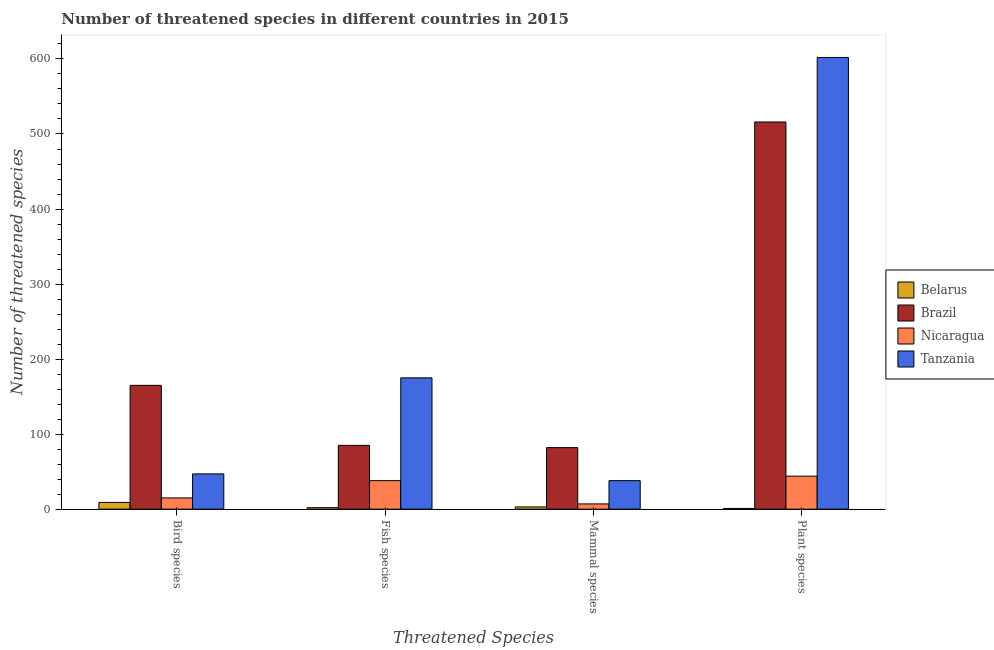How many groups of bars are there?
Make the answer very short. 4. Are the number of bars per tick equal to the number of legend labels?
Your answer should be very brief. Yes. Are the number of bars on each tick of the X-axis equal?
Provide a succinct answer. Yes. How many bars are there on the 1st tick from the left?
Your response must be concise. 4. How many bars are there on the 4th tick from the right?
Your answer should be very brief. 4. What is the label of the 1st group of bars from the left?
Make the answer very short. Bird species. What is the number of threatened bird species in Brazil?
Provide a succinct answer. 165. Across all countries, what is the maximum number of threatened mammal species?
Offer a terse response. 82. Across all countries, what is the minimum number of threatened fish species?
Give a very brief answer. 2. In which country was the number of threatened bird species maximum?
Offer a very short reply. Brazil. In which country was the number of threatened mammal species minimum?
Make the answer very short. Belarus. What is the total number of threatened fish species in the graph?
Provide a succinct answer. 300. What is the difference between the number of threatened plant species in Belarus and that in Tanzania?
Ensure brevity in your answer.  -601. What is the difference between the number of threatened bird species in Tanzania and the number of threatened plant species in Belarus?
Offer a terse response. 46. What is the average number of threatened fish species per country?
Make the answer very short. 75. What is the difference between the number of threatened plant species and number of threatened mammal species in Nicaragua?
Offer a terse response. 37. What is the ratio of the number of threatened bird species in Tanzania to that in Brazil?
Provide a short and direct response. 0.28. Is the number of threatened bird species in Brazil less than that in Belarus?
Give a very brief answer. No. What is the difference between the highest and the second highest number of threatened bird species?
Your answer should be compact. 118. What is the difference between the highest and the lowest number of threatened fish species?
Your answer should be very brief. 173. In how many countries, is the number of threatened mammal species greater than the average number of threatened mammal species taken over all countries?
Provide a succinct answer. 2. Is the sum of the number of threatened bird species in Nicaragua and Belarus greater than the maximum number of threatened mammal species across all countries?
Your response must be concise. No. Is it the case that in every country, the sum of the number of threatened plant species and number of threatened mammal species is greater than the sum of number of threatened bird species and number of threatened fish species?
Your response must be concise. No. What does the 3rd bar from the left in Plant species represents?
Offer a terse response. Nicaragua. What does the 2nd bar from the right in Plant species represents?
Keep it short and to the point. Nicaragua. Is it the case that in every country, the sum of the number of threatened bird species and number of threatened fish species is greater than the number of threatened mammal species?
Your answer should be compact. Yes. Are all the bars in the graph horizontal?
Your answer should be very brief. No. How many countries are there in the graph?
Provide a succinct answer. 4. What is the title of the graph?
Offer a terse response. Number of threatened species in different countries in 2015. What is the label or title of the X-axis?
Your answer should be compact. Threatened Species. What is the label or title of the Y-axis?
Offer a very short reply. Number of threatened species. What is the Number of threatened species of Brazil in Bird species?
Your answer should be very brief. 165. What is the Number of threatened species of Belarus in Fish species?
Ensure brevity in your answer.  2. What is the Number of threatened species in Brazil in Fish species?
Your answer should be very brief. 85. What is the Number of threatened species of Tanzania in Fish species?
Keep it short and to the point. 175. What is the Number of threatened species of Nicaragua in Mammal species?
Your answer should be compact. 7. What is the Number of threatened species in Tanzania in Mammal species?
Offer a very short reply. 38. What is the Number of threatened species of Belarus in Plant species?
Keep it short and to the point. 1. What is the Number of threatened species of Brazil in Plant species?
Provide a short and direct response. 516. What is the Number of threatened species of Tanzania in Plant species?
Make the answer very short. 602. Across all Threatened Species, what is the maximum Number of threatened species of Brazil?
Give a very brief answer. 516. Across all Threatened Species, what is the maximum Number of threatened species in Tanzania?
Provide a succinct answer. 602. Across all Threatened Species, what is the minimum Number of threatened species in Brazil?
Provide a short and direct response. 82. Across all Threatened Species, what is the minimum Number of threatened species in Nicaragua?
Offer a terse response. 7. What is the total Number of threatened species in Brazil in the graph?
Your answer should be very brief. 848. What is the total Number of threatened species of Nicaragua in the graph?
Your answer should be compact. 104. What is the total Number of threatened species of Tanzania in the graph?
Make the answer very short. 862. What is the difference between the Number of threatened species in Brazil in Bird species and that in Fish species?
Provide a short and direct response. 80. What is the difference between the Number of threatened species in Tanzania in Bird species and that in Fish species?
Provide a short and direct response. -128. What is the difference between the Number of threatened species of Tanzania in Bird species and that in Mammal species?
Provide a succinct answer. 9. What is the difference between the Number of threatened species of Belarus in Bird species and that in Plant species?
Provide a succinct answer. 8. What is the difference between the Number of threatened species in Brazil in Bird species and that in Plant species?
Keep it short and to the point. -351. What is the difference between the Number of threatened species in Tanzania in Bird species and that in Plant species?
Give a very brief answer. -555. What is the difference between the Number of threatened species of Brazil in Fish species and that in Mammal species?
Offer a terse response. 3. What is the difference between the Number of threatened species of Tanzania in Fish species and that in Mammal species?
Your answer should be compact. 137. What is the difference between the Number of threatened species in Brazil in Fish species and that in Plant species?
Your response must be concise. -431. What is the difference between the Number of threatened species of Nicaragua in Fish species and that in Plant species?
Ensure brevity in your answer.  -6. What is the difference between the Number of threatened species of Tanzania in Fish species and that in Plant species?
Keep it short and to the point. -427. What is the difference between the Number of threatened species of Belarus in Mammal species and that in Plant species?
Make the answer very short. 2. What is the difference between the Number of threatened species in Brazil in Mammal species and that in Plant species?
Give a very brief answer. -434. What is the difference between the Number of threatened species in Nicaragua in Mammal species and that in Plant species?
Ensure brevity in your answer.  -37. What is the difference between the Number of threatened species in Tanzania in Mammal species and that in Plant species?
Your answer should be compact. -564. What is the difference between the Number of threatened species of Belarus in Bird species and the Number of threatened species of Brazil in Fish species?
Ensure brevity in your answer.  -76. What is the difference between the Number of threatened species of Belarus in Bird species and the Number of threatened species of Nicaragua in Fish species?
Give a very brief answer. -29. What is the difference between the Number of threatened species of Belarus in Bird species and the Number of threatened species of Tanzania in Fish species?
Your answer should be very brief. -166. What is the difference between the Number of threatened species in Brazil in Bird species and the Number of threatened species in Nicaragua in Fish species?
Provide a succinct answer. 127. What is the difference between the Number of threatened species in Nicaragua in Bird species and the Number of threatened species in Tanzania in Fish species?
Your response must be concise. -160. What is the difference between the Number of threatened species in Belarus in Bird species and the Number of threatened species in Brazil in Mammal species?
Provide a short and direct response. -73. What is the difference between the Number of threatened species of Belarus in Bird species and the Number of threatened species of Tanzania in Mammal species?
Give a very brief answer. -29. What is the difference between the Number of threatened species of Brazil in Bird species and the Number of threatened species of Nicaragua in Mammal species?
Make the answer very short. 158. What is the difference between the Number of threatened species of Brazil in Bird species and the Number of threatened species of Tanzania in Mammal species?
Offer a terse response. 127. What is the difference between the Number of threatened species of Belarus in Bird species and the Number of threatened species of Brazil in Plant species?
Keep it short and to the point. -507. What is the difference between the Number of threatened species of Belarus in Bird species and the Number of threatened species of Nicaragua in Plant species?
Keep it short and to the point. -35. What is the difference between the Number of threatened species of Belarus in Bird species and the Number of threatened species of Tanzania in Plant species?
Your answer should be compact. -593. What is the difference between the Number of threatened species in Brazil in Bird species and the Number of threatened species in Nicaragua in Plant species?
Your response must be concise. 121. What is the difference between the Number of threatened species of Brazil in Bird species and the Number of threatened species of Tanzania in Plant species?
Your answer should be compact. -437. What is the difference between the Number of threatened species in Nicaragua in Bird species and the Number of threatened species in Tanzania in Plant species?
Offer a terse response. -587. What is the difference between the Number of threatened species in Belarus in Fish species and the Number of threatened species in Brazil in Mammal species?
Provide a succinct answer. -80. What is the difference between the Number of threatened species in Belarus in Fish species and the Number of threatened species in Tanzania in Mammal species?
Your response must be concise. -36. What is the difference between the Number of threatened species of Brazil in Fish species and the Number of threatened species of Tanzania in Mammal species?
Your answer should be very brief. 47. What is the difference between the Number of threatened species in Nicaragua in Fish species and the Number of threatened species in Tanzania in Mammal species?
Ensure brevity in your answer.  0. What is the difference between the Number of threatened species of Belarus in Fish species and the Number of threatened species of Brazil in Plant species?
Your answer should be very brief. -514. What is the difference between the Number of threatened species in Belarus in Fish species and the Number of threatened species in Nicaragua in Plant species?
Provide a short and direct response. -42. What is the difference between the Number of threatened species of Belarus in Fish species and the Number of threatened species of Tanzania in Plant species?
Make the answer very short. -600. What is the difference between the Number of threatened species in Brazil in Fish species and the Number of threatened species in Tanzania in Plant species?
Provide a short and direct response. -517. What is the difference between the Number of threatened species in Nicaragua in Fish species and the Number of threatened species in Tanzania in Plant species?
Your answer should be compact. -564. What is the difference between the Number of threatened species in Belarus in Mammal species and the Number of threatened species in Brazil in Plant species?
Keep it short and to the point. -513. What is the difference between the Number of threatened species of Belarus in Mammal species and the Number of threatened species of Nicaragua in Plant species?
Your response must be concise. -41. What is the difference between the Number of threatened species in Belarus in Mammal species and the Number of threatened species in Tanzania in Plant species?
Offer a terse response. -599. What is the difference between the Number of threatened species in Brazil in Mammal species and the Number of threatened species in Tanzania in Plant species?
Offer a terse response. -520. What is the difference between the Number of threatened species of Nicaragua in Mammal species and the Number of threatened species of Tanzania in Plant species?
Offer a terse response. -595. What is the average Number of threatened species of Belarus per Threatened Species?
Provide a succinct answer. 3.75. What is the average Number of threatened species of Brazil per Threatened Species?
Your answer should be compact. 212. What is the average Number of threatened species in Nicaragua per Threatened Species?
Your answer should be compact. 26. What is the average Number of threatened species in Tanzania per Threatened Species?
Provide a short and direct response. 215.5. What is the difference between the Number of threatened species of Belarus and Number of threatened species of Brazil in Bird species?
Make the answer very short. -156. What is the difference between the Number of threatened species of Belarus and Number of threatened species of Nicaragua in Bird species?
Make the answer very short. -6. What is the difference between the Number of threatened species in Belarus and Number of threatened species in Tanzania in Bird species?
Offer a terse response. -38. What is the difference between the Number of threatened species of Brazil and Number of threatened species of Nicaragua in Bird species?
Provide a succinct answer. 150. What is the difference between the Number of threatened species of Brazil and Number of threatened species of Tanzania in Bird species?
Ensure brevity in your answer.  118. What is the difference between the Number of threatened species of Nicaragua and Number of threatened species of Tanzania in Bird species?
Provide a short and direct response. -32. What is the difference between the Number of threatened species of Belarus and Number of threatened species of Brazil in Fish species?
Your answer should be compact. -83. What is the difference between the Number of threatened species of Belarus and Number of threatened species of Nicaragua in Fish species?
Give a very brief answer. -36. What is the difference between the Number of threatened species of Belarus and Number of threatened species of Tanzania in Fish species?
Your response must be concise. -173. What is the difference between the Number of threatened species in Brazil and Number of threatened species in Tanzania in Fish species?
Your answer should be very brief. -90. What is the difference between the Number of threatened species of Nicaragua and Number of threatened species of Tanzania in Fish species?
Your response must be concise. -137. What is the difference between the Number of threatened species of Belarus and Number of threatened species of Brazil in Mammal species?
Provide a succinct answer. -79. What is the difference between the Number of threatened species in Belarus and Number of threatened species in Tanzania in Mammal species?
Make the answer very short. -35. What is the difference between the Number of threatened species of Brazil and Number of threatened species of Tanzania in Mammal species?
Offer a terse response. 44. What is the difference between the Number of threatened species of Nicaragua and Number of threatened species of Tanzania in Mammal species?
Keep it short and to the point. -31. What is the difference between the Number of threatened species of Belarus and Number of threatened species of Brazil in Plant species?
Ensure brevity in your answer.  -515. What is the difference between the Number of threatened species in Belarus and Number of threatened species in Nicaragua in Plant species?
Keep it short and to the point. -43. What is the difference between the Number of threatened species of Belarus and Number of threatened species of Tanzania in Plant species?
Provide a short and direct response. -601. What is the difference between the Number of threatened species of Brazil and Number of threatened species of Nicaragua in Plant species?
Offer a terse response. 472. What is the difference between the Number of threatened species in Brazil and Number of threatened species in Tanzania in Plant species?
Provide a succinct answer. -86. What is the difference between the Number of threatened species of Nicaragua and Number of threatened species of Tanzania in Plant species?
Offer a very short reply. -558. What is the ratio of the Number of threatened species of Brazil in Bird species to that in Fish species?
Your response must be concise. 1.94. What is the ratio of the Number of threatened species in Nicaragua in Bird species to that in Fish species?
Make the answer very short. 0.39. What is the ratio of the Number of threatened species in Tanzania in Bird species to that in Fish species?
Your answer should be compact. 0.27. What is the ratio of the Number of threatened species in Belarus in Bird species to that in Mammal species?
Provide a short and direct response. 3. What is the ratio of the Number of threatened species of Brazil in Bird species to that in Mammal species?
Ensure brevity in your answer.  2.01. What is the ratio of the Number of threatened species in Nicaragua in Bird species to that in Mammal species?
Provide a succinct answer. 2.14. What is the ratio of the Number of threatened species in Tanzania in Bird species to that in Mammal species?
Your response must be concise. 1.24. What is the ratio of the Number of threatened species of Brazil in Bird species to that in Plant species?
Give a very brief answer. 0.32. What is the ratio of the Number of threatened species in Nicaragua in Bird species to that in Plant species?
Ensure brevity in your answer.  0.34. What is the ratio of the Number of threatened species of Tanzania in Bird species to that in Plant species?
Provide a short and direct response. 0.08. What is the ratio of the Number of threatened species of Brazil in Fish species to that in Mammal species?
Offer a very short reply. 1.04. What is the ratio of the Number of threatened species in Nicaragua in Fish species to that in Mammal species?
Your response must be concise. 5.43. What is the ratio of the Number of threatened species in Tanzania in Fish species to that in Mammal species?
Your response must be concise. 4.61. What is the ratio of the Number of threatened species in Belarus in Fish species to that in Plant species?
Provide a succinct answer. 2. What is the ratio of the Number of threatened species in Brazil in Fish species to that in Plant species?
Give a very brief answer. 0.16. What is the ratio of the Number of threatened species in Nicaragua in Fish species to that in Plant species?
Make the answer very short. 0.86. What is the ratio of the Number of threatened species of Tanzania in Fish species to that in Plant species?
Make the answer very short. 0.29. What is the ratio of the Number of threatened species in Belarus in Mammal species to that in Plant species?
Provide a short and direct response. 3. What is the ratio of the Number of threatened species of Brazil in Mammal species to that in Plant species?
Provide a succinct answer. 0.16. What is the ratio of the Number of threatened species in Nicaragua in Mammal species to that in Plant species?
Offer a very short reply. 0.16. What is the ratio of the Number of threatened species in Tanzania in Mammal species to that in Plant species?
Your response must be concise. 0.06. What is the difference between the highest and the second highest Number of threatened species of Belarus?
Ensure brevity in your answer.  6. What is the difference between the highest and the second highest Number of threatened species of Brazil?
Ensure brevity in your answer.  351. What is the difference between the highest and the second highest Number of threatened species of Tanzania?
Provide a succinct answer. 427. What is the difference between the highest and the lowest Number of threatened species of Brazil?
Provide a short and direct response. 434. What is the difference between the highest and the lowest Number of threatened species of Nicaragua?
Offer a terse response. 37. What is the difference between the highest and the lowest Number of threatened species in Tanzania?
Make the answer very short. 564. 